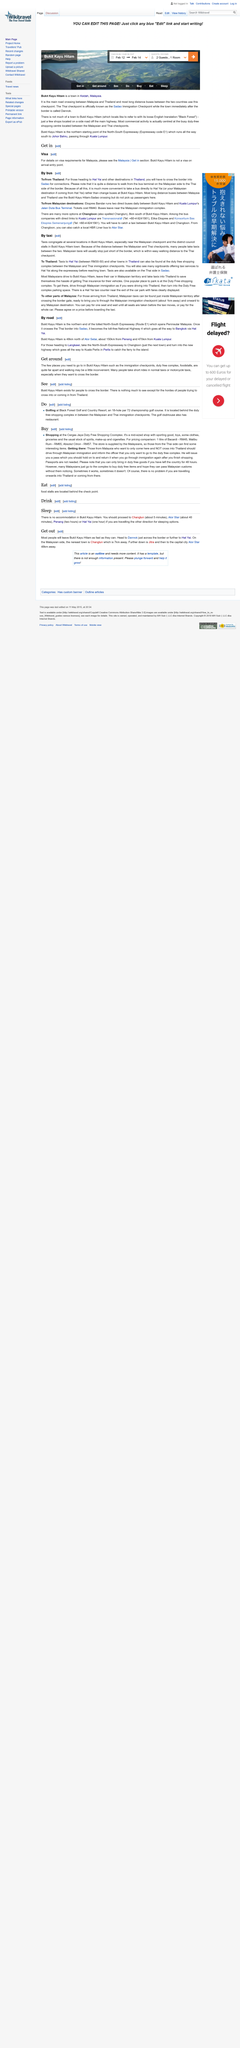Indicate a few pertinent items in this graphic. Yes, both taking a bus and getting a visa are elements of entering Malaysia. Visitors traveling to Hai Yat will need to cross the border into Sadao in order to connect to their next destination. Bukit Kayu Hitam can be loosely translated to Black Forest. In Bukit Kayu Hitam, taxis frequently gather around the Malaysian check point and the District Council stalls. Bukit Kayu Hitam is a town located in the state of Kedah, Malaysia. 